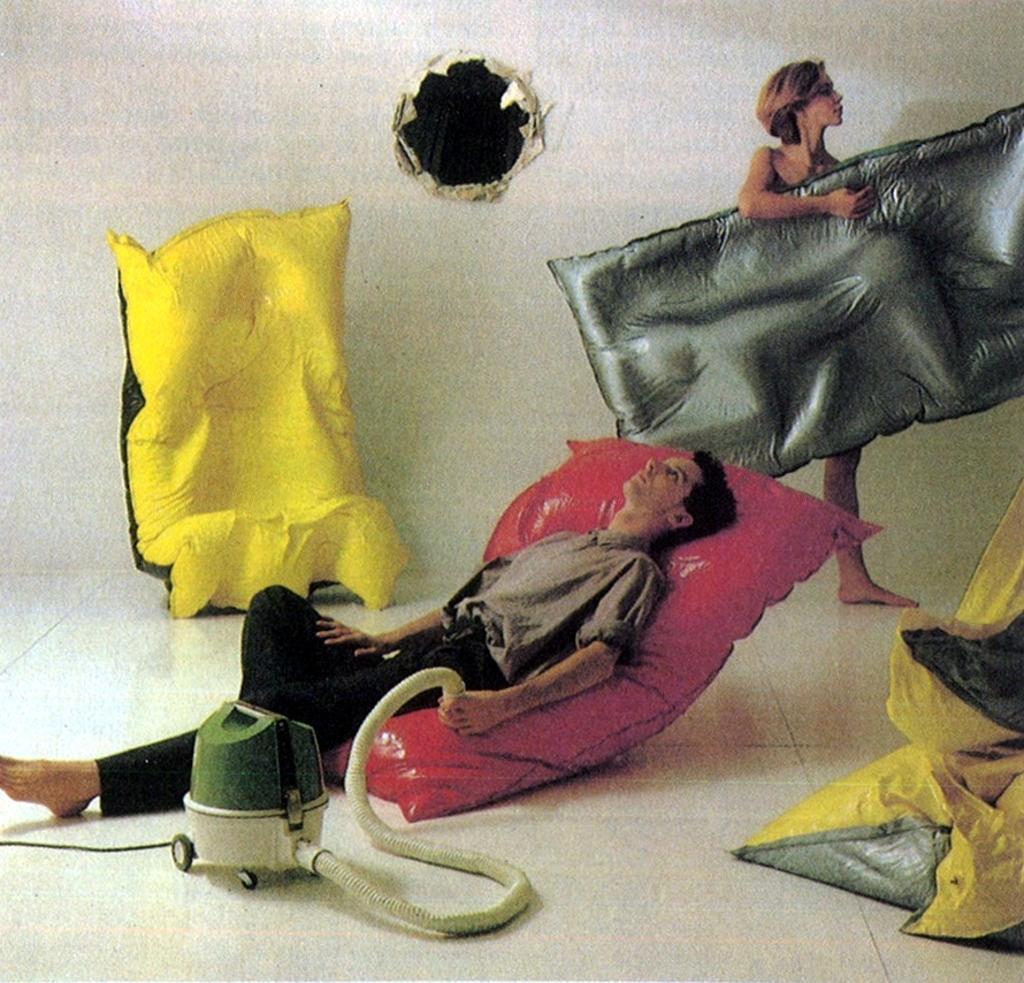Could you give a brief overview of what you see in this image? There is one man lying on an air mattress at the bottom of this image, and there is one woman holding an air mattress on the right side of this image, we can see a yellow color air mattress present on the left side of this image, and there is a wall in the background. we can see a hole to the wall at the top of this image. 